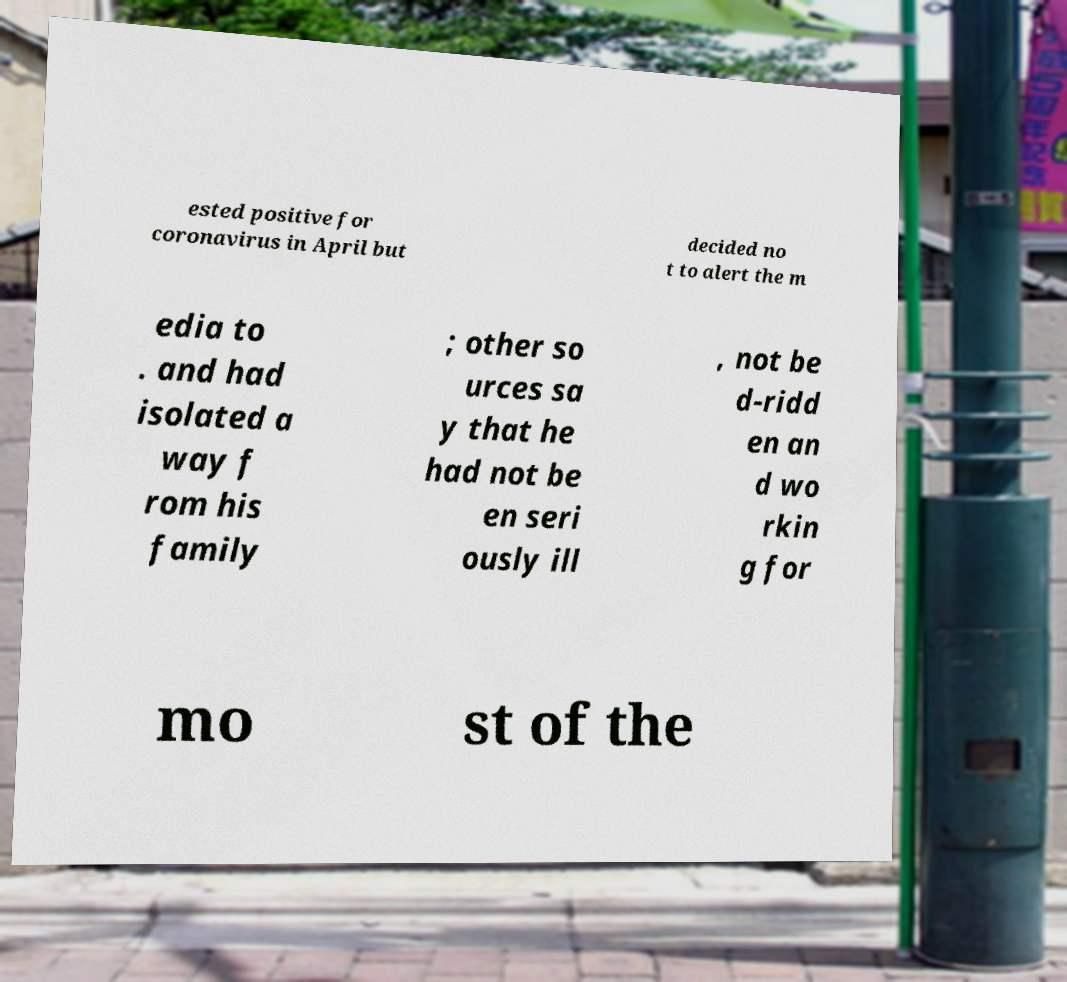Could you assist in decoding the text presented in this image and type it out clearly? ested positive for coronavirus in April but decided no t to alert the m edia to . and had isolated a way f rom his family ; other so urces sa y that he had not be en seri ously ill , not be d-ridd en an d wo rkin g for mo st of the 